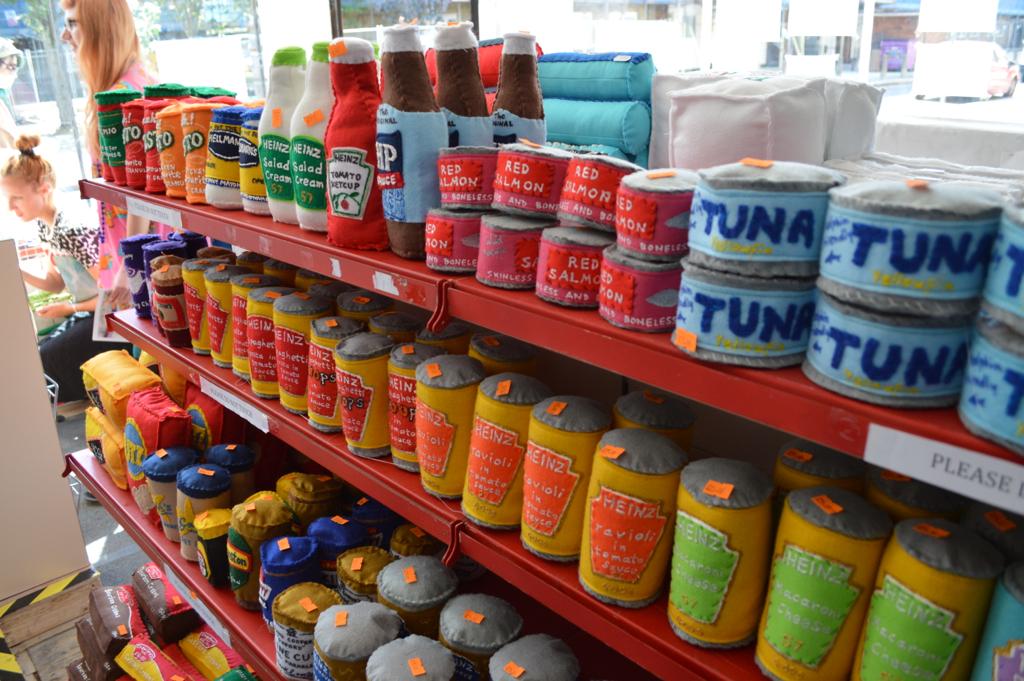What kind of fish is sold here?
Offer a terse response. Tuna. What brand of the tomato ketchup available here?
Ensure brevity in your answer.  Heinz. 